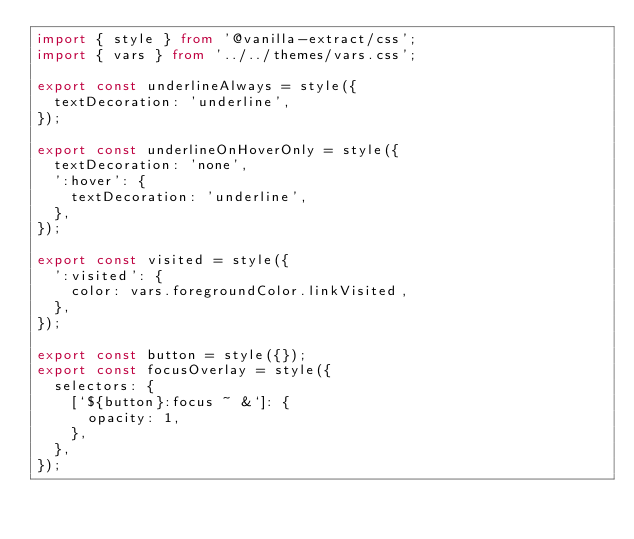<code> <loc_0><loc_0><loc_500><loc_500><_TypeScript_>import { style } from '@vanilla-extract/css';
import { vars } from '../../themes/vars.css';

export const underlineAlways = style({
  textDecoration: 'underline',
});

export const underlineOnHoverOnly = style({
  textDecoration: 'none',
  ':hover': {
    textDecoration: 'underline',
  },
});

export const visited = style({
  ':visited': {
    color: vars.foregroundColor.linkVisited,
  },
});

export const button = style({});
export const focusOverlay = style({
  selectors: {
    [`${button}:focus ~ &`]: {
      opacity: 1,
    },
  },
});
</code> 